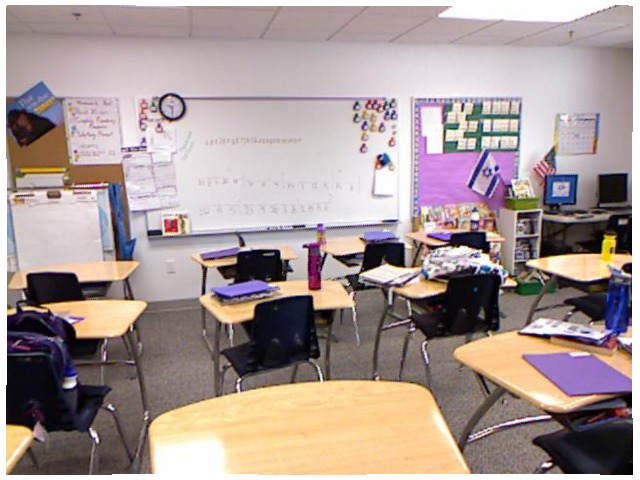<image>
Can you confirm if the desk is in front of the chair? No. The desk is not in front of the chair. The spatial positioning shows a different relationship between these objects. Where is the book in relation to the desk? Is it on the desk? No. The book is not positioned on the desk. They may be near each other, but the book is not supported by or resting on top of the desk. Where is the folder in relation to the desk? Is it on the desk? No. The folder is not positioned on the desk. They may be near each other, but the folder is not supported by or resting on top of the desk. Is the chair to the left of the table? No. The chair is not to the left of the table. From this viewpoint, they have a different horizontal relationship. Where is the chair in relation to the desk? Is it to the left of the desk? No. The chair is not to the left of the desk. From this viewpoint, they have a different horizontal relationship. 